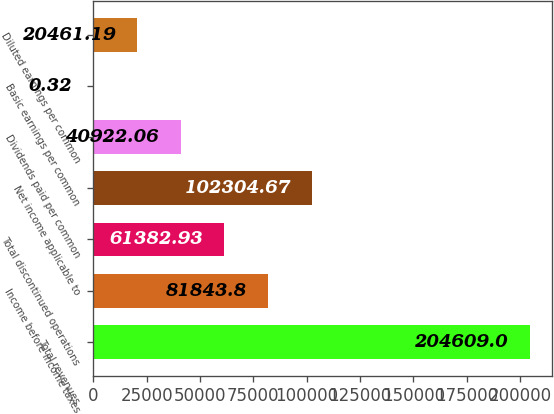Convert chart to OTSL. <chart><loc_0><loc_0><loc_500><loc_500><bar_chart><fcel>Total revenues<fcel>Income before income taxes<fcel>Total discontinued operations<fcel>Net income applicable to<fcel>Dividends paid per common<fcel>Basic earnings per common<fcel>Diluted earnings per common<nl><fcel>204609<fcel>81843.8<fcel>61382.9<fcel>102305<fcel>40922.1<fcel>0.32<fcel>20461.2<nl></chart> 